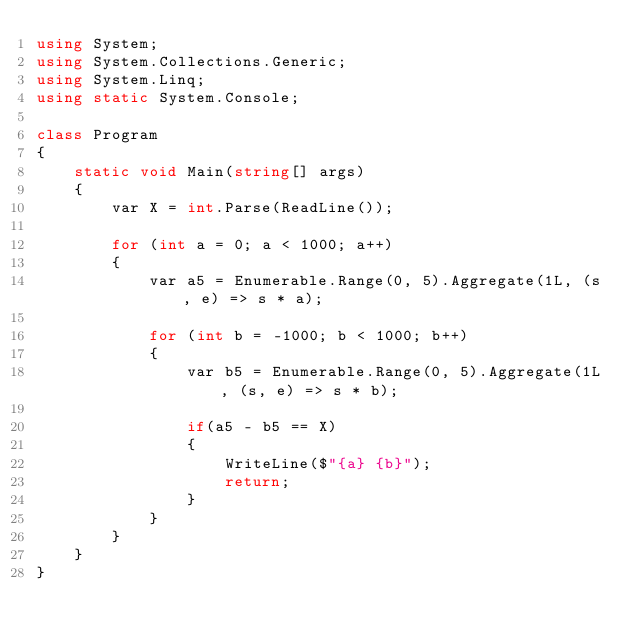Convert code to text. <code><loc_0><loc_0><loc_500><loc_500><_C#_>using System;
using System.Collections.Generic;
using System.Linq;
using static System.Console;

class Program
{
    static void Main(string[] args)
    {
        var X = int.Parse(ReadLine());

        for (int a = 0; a < 1000; a++)
        {
            var a5 = Enumerable.Range(0, 5).Aggregate(1L, (s, e) => s * a);

            for (int b = -1000; b < 1000; b++)
            {
                var b5 = Enumerable.Range(0, 5).Aggregate(1L, (s, e) => s * b);

                if(a5 - b5 == X)
                {
                    WriteLine($"{a} {b}");
                    return;
                }
            }
        }
    }
}
</code> 